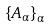<formula> <loc_0><loc_0><loc_500><loc_500>\left \{ A _ { \alpha } \right \} _ { \alpha }</formula> 